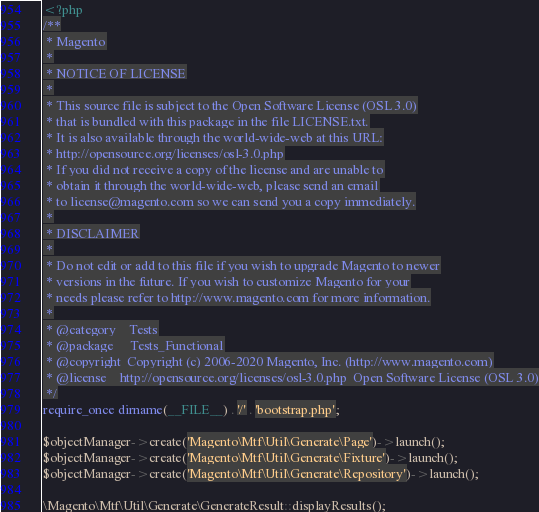Convert code to text. <code><loc_0><loc_0><loc_500><loc_500><_PHP_><?php
/**
 * Magento
 *
 * NOTICE OF LICENSE
 *
 * This source file is subject to the Open Software License (OSL 3.0)
 * that is bundled with this package in the file LICENSE.txt.
 * It is also available through the world-wide-web at this URL:
 * http://opensource.org/licenses/osl-3.0.php
 * If you did not receive a copy of the license and are unable to
 * obtain it through the world-wide-web, please send an email
 * to license@magento.com so we can send you a copy immediately.
 *
 * DISCLAIMER
 *
 * Do not edit or add to this file if you wish to upgrade Magento to newer
 * versions in the future. If you wish to customize Magento for your
 * needs please refer to http://www.magento.com for more information.
 *
 * @category    Tests
 * @package     Tests_Functional
 * @copyright  Copyright (c) 2006-2020 Magento, Inc. (http://www.magento.com)
 * @license    http://opensource.org/licenses/osl-3.0.php  Open Software License (OSL 3.0)
 */
require_once dirname(__FILE__) . '/' . 'bootstrap.php';

$objectManager->create('Magento\Mtf\Util\Generate\Page')->launch();
$objectManager->create('Magento\Mtf\Util\Generate\Fixture')->launch();
$objectManager->create('Magento\Mtf\Util\Generate\Repository')->launch();

\Magento\Mtf\Util\Generate\GenerateResult::displayResults();
</code> 